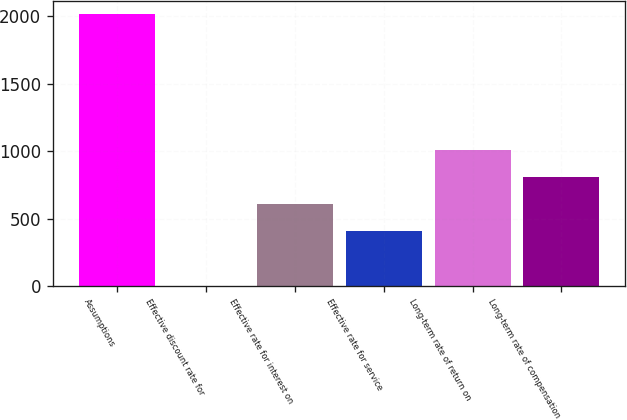Convert chart. <chart><loc_0><loc_0><loc_500><loc_500><bar_chart><fcel>Assumptions<fcel>Effective discount rate for<fcel>Effective rate for interest on<fcel>Effective rate for service<fcel>Long-term rate of return on<fcel>Long-term rate of compensation<nl><fcel>2015<fcel>3.03<fcel>606.63<fcel>405.43<fcel>1009.03<fcel>807.83<nl></chart> 